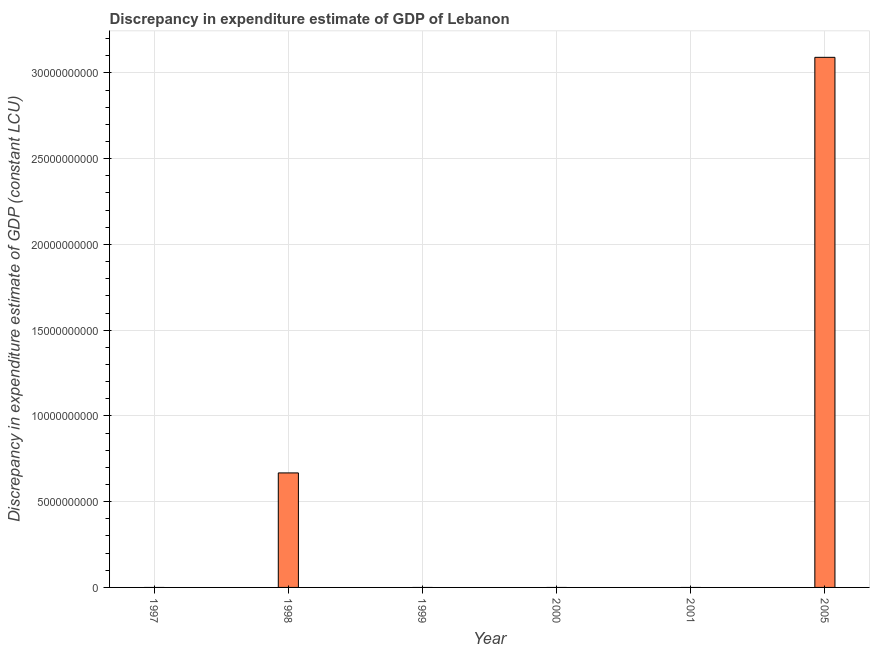Does the graph contain any zero values?
Provide a short and direct response. Yes. Does the graph contain grids?
Provide a succinct answer. Yes. What is the title of the graph?
Offer a terse response. Discrepancy in expenditure estimate of GDP of Lebanon. What is the label or title of the X-axis?
Make the answer very short. Year. What is the label or title of the Y-axis?
Your response must be concise. Discrepancy in expenditure estimate of GDP (constant LCU). What is the discrepancy in expenditure estimate of gdp in 1999?
Offer a terse response. 0. Across all years, what is the maximum discrepancy in expenditure estimate of gdp?
Your answer should be compact. 3.09e+1. In which year was the discrepancy in expenditure estimate of gdp maximum?
Provide a succinct answer. 2005. What is the sum of the discrepancy in expenditure estimate of gdp?
Your answer should be very brief. 3.76e+1. What is the difference between the discrepancy in expenditure estimate of gdp in 1998 and 2005?
Your answer should be very brief. -2.42e+1. What is the average discrepancy in expenditure estimate of gdp per year?
Your answer should be compact. 6.26e+09. What is the difference between the highest and the lowest discrepancy in expenditure estimate of gdp?
Keep it short and to the point. 3.09e+1. In how many years, is the discrepancy in expenditure estimate of gdp greater than the average discrepancy in expenditure estimate of gdp taken over all years?
Offer a very short reply. 2. Are all the bars in the graph horizontal?
Make the answer very short. No. What is the Discrepancy in expenditure estimate of GDP (constant LCU) of 1998?
Ensure brevity in your answer.  6.68e+09. What is the Discrepancy in expenditure estimate of GDP (constant LCU) of 1999?
Make the answer very short. 0. What is the Discrepancy in expenditure estimate of GDP (constant LCU) of 2000?
Provide a succinct answer. 0. What is the Discrepancy in expenditure estimate of GDP (constant LCU) of 2005?
Offer a terse response. 3.09e+1. What is the difference between the Discrepancy in expenditure estimate of GDP (constant LCU) in 1998 and 2005?
Provide a succinct answer. -2.42e+1. What is the ratio of the Discrepancy in expenditure estimate of GDP (constant LCU) in 1998 to that in 2005?
Give a very brief answer. 0.22. 